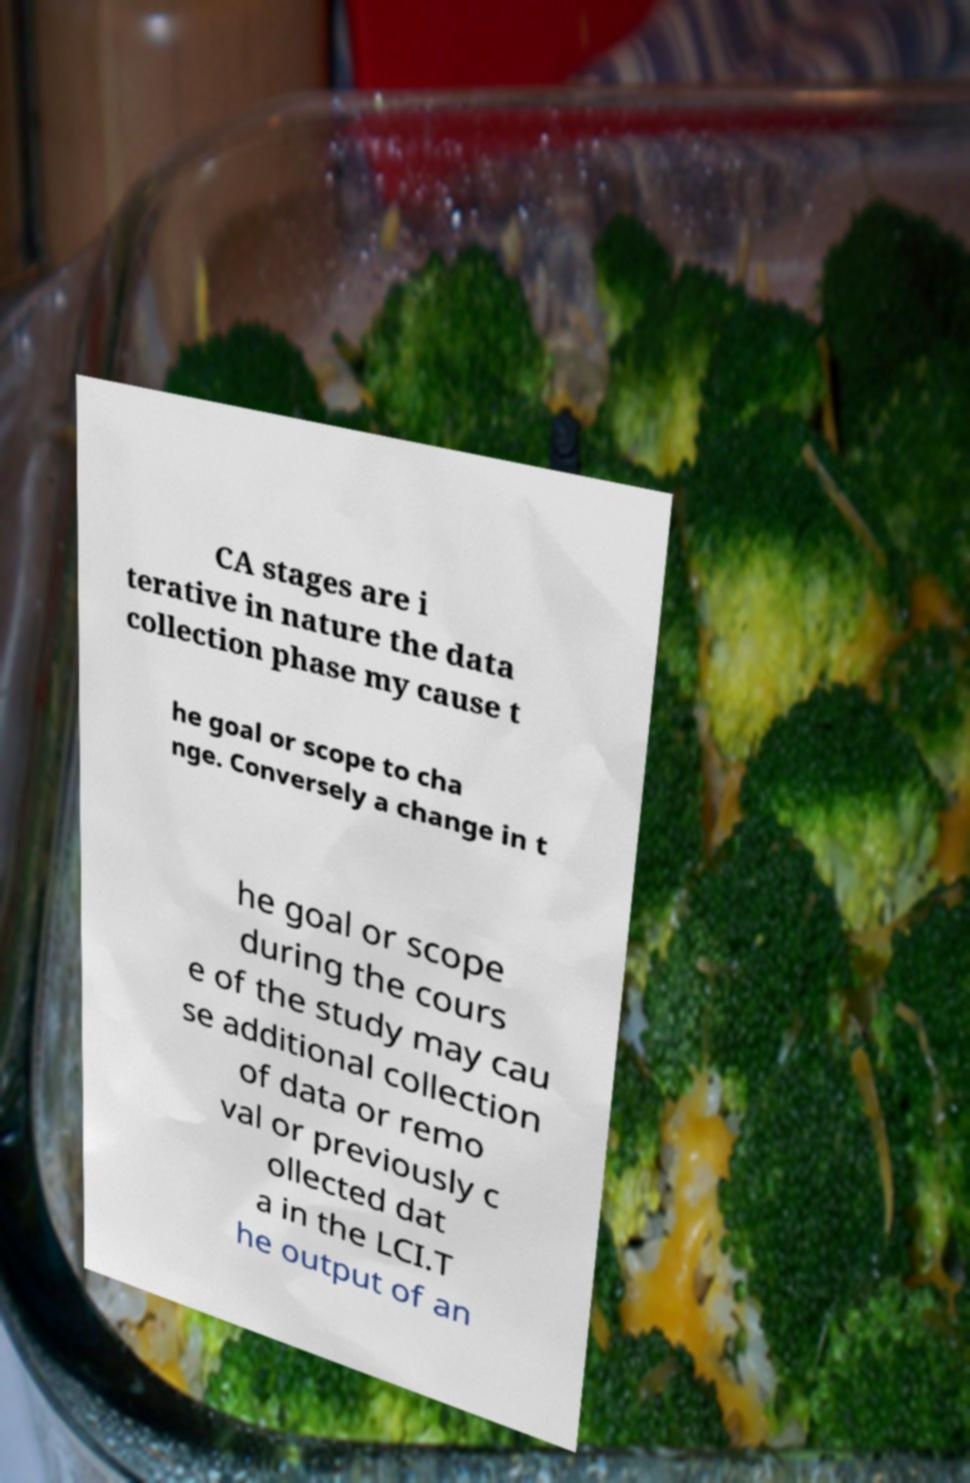There's text embedded in this image that I need extracted. Can you transcribe it verbatim? CA stages are i terative in nature the data collection phase my cause t he goal or scope to cha nge. Conversely a change in t he goal or scope during the cours e of the study may cau se additional collection of data or remo val or previously c ollected dat a in the LCI.T he output of an 